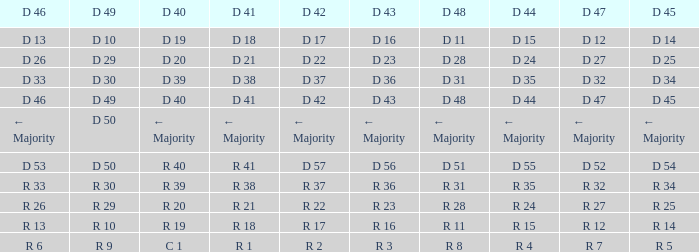I want the D 46 for D 45 of r 5 R 6. 